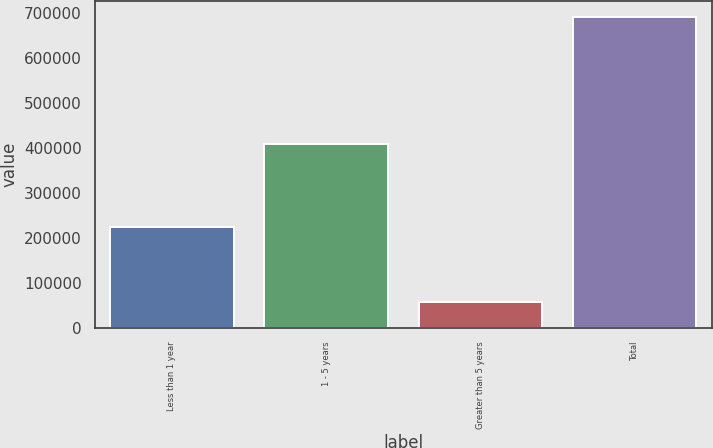Convert chart to OTSL. <chart><loc_0><loc_0><loc_500><loc_500><bar_chart><fcel>Less than 1 year<fcel>1 - 5 years<fcel>Greater than 5 years<fcel>Total<nl><fcel>223191<fcel>409092<fcel>58183<fcel>690466<nl></chart> 